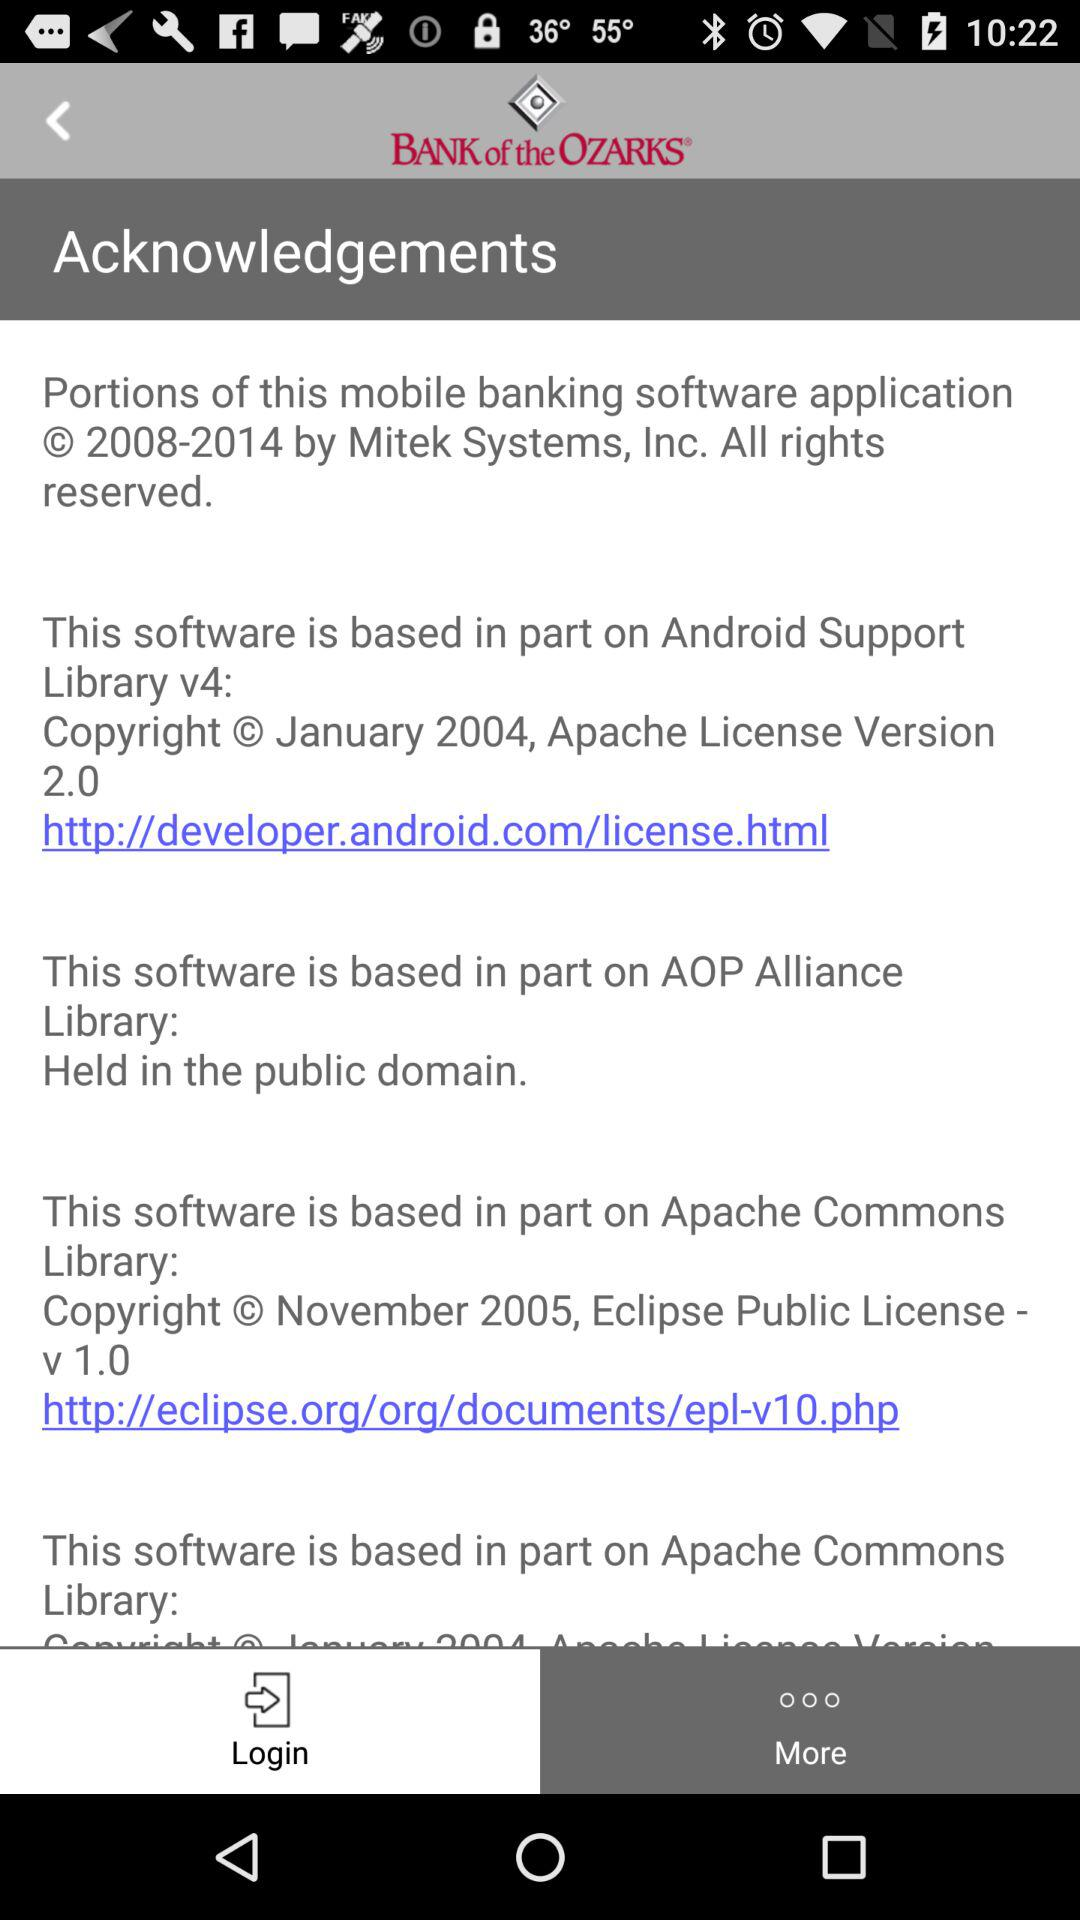What is the email address?
When the provided information is insufficient, respond with <no answer>. <no answer> 